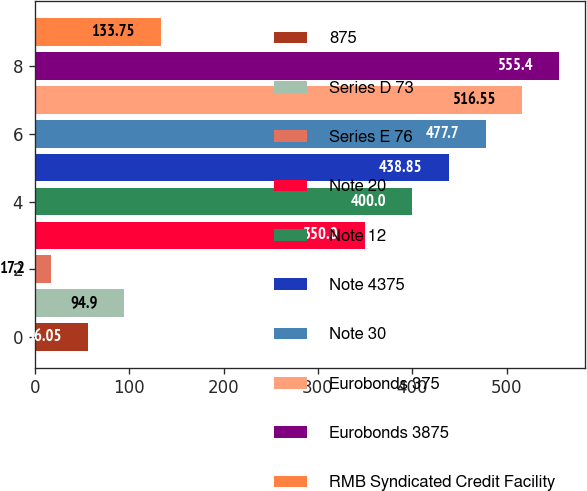<chart> <loc_0><loc_0><loc_500><loc_500><bar_chart><fcel>875<fcel>Series D 73<fcel>Series E 76<fcel>Note 20<fcel>Note 12<fcel>Note 4375<fcel>Note 30<fcel>Eurobonds 375<fcel>Eurobonds 3875<fcel>RMB Syndicated Credit Facility<nl><fcel>56.05<fcel>94.9<fcel>17.2<fcel>350<fcel>400<fcel>438.85<fcel>477.7<fcel>516.55<fcel>555.4<fcel>133.75<nl></chart> 